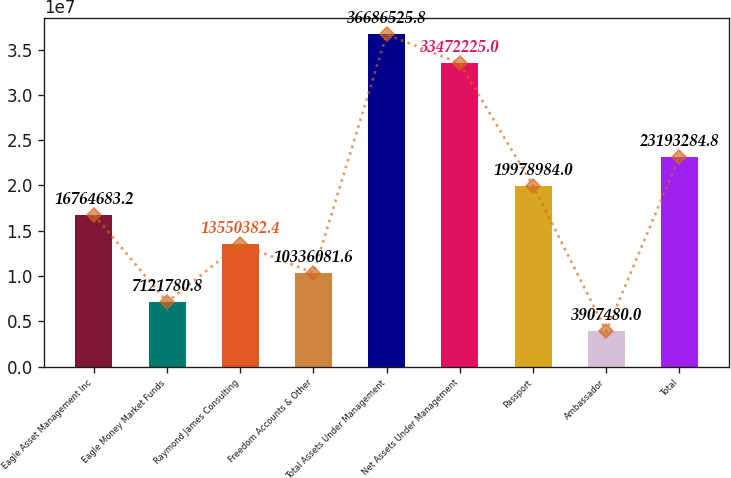Convert chart to OTSL. <chart><loc_0><loc_0><loc_500><loc_500><bar_chart><fcel>Eagle Asset Management Inc<fcel>Eagle Money Market Funds<fcel>Raymond James Consulting<fcel>Freedom Accounts & Other<fcel>Total Assets Under Management<fcel>Net Assets Under Management<fcel>Passport<fcel>Ambassador<fcel>Total<nl><fcel>1.67647e+07<fcel>7.12178e+06<fcel>1.35504e+07<fcel>1.03361e+07<fcel>3.66865e+07<fcel>3.34722e+07<fcel>1.9979e+07<fcel>3.90748e+06<fcel>2.31933e+07<nl></chart> 